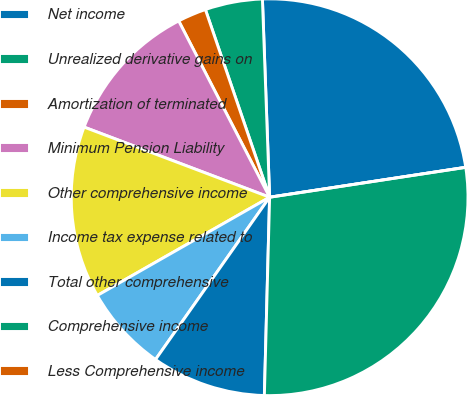Convert chart to OTSL. <chart><loc_0><loc_0><loc_500><loc_500><pie_chart><fcel>Net income<fcel>Unrealized derivative gains on<fcel>Amortization of terminated<fcel>Minimum Pension Liability<fcel>Other comprehensive income<fcel>Income tax expense related to<fcel>Total other comprehensive<fcel>Comprehensive income<fcel>Less Comprehensive income<nl><fcel>23.17%<fcel>4.67%<fcel>2.33%<fcel>11.67%<fcel>14.0%<fcel>7.0%<fcel>9.33%<fcel>27.83%<fcel>0.0%<nl></chart> 